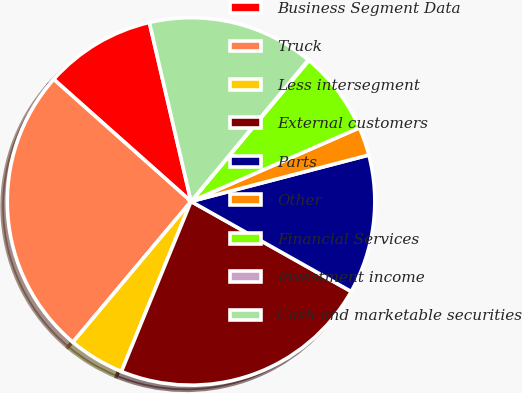Convert chart to OTSL. <chart><loc_0><loc_0><loc_500><loc_500><pie_chart><fcel>Business Segment Data<fcel>Truck<fcel>Less intersegment<fcel>External customers<fcel>Parts<fcel>Other<fcel>Financial Services<fcel>Investment income<fcel>Cash and marketable securities<nl><fcel>9.79%<fcel>25.46%<fcel>4.93%<fcel>23.03%<fcel>12.22%<fcel>2.5%<fcel>7.36%<fcel>0.07%<fcel>14.65%<nl></chart> 